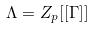Convert formula to latex. <formula><loc_0><loc_0><loc_500><loc_500>\Lambda = Z _ { p } [ [ \Gamma ] ]</formula> 